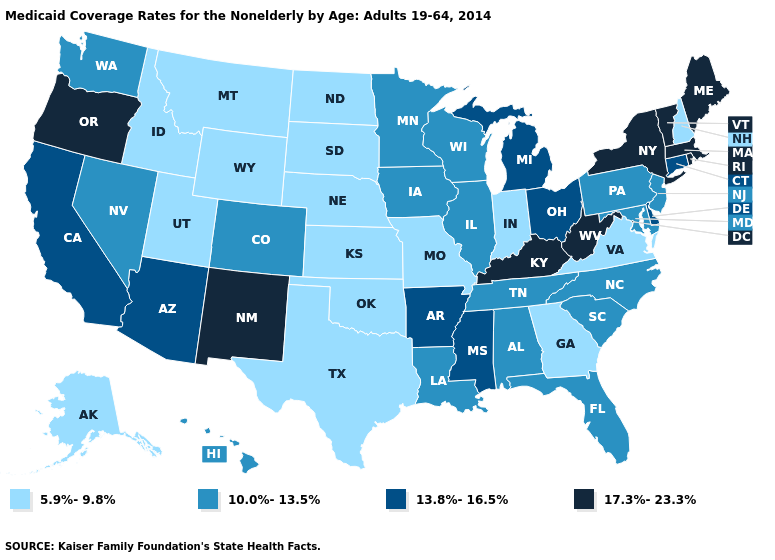What is the value of New Mexico?
Quick response, please. 17.3%-23.3%. Which states have the lowest value in the West?
Be succinct. Alaska, Idaho, Montana, Utah, Wyoming. Name the states that have a value in the range 10.0%-13.5%?
Be succinct. Alabama, Colorado, Florida, Hawaii, Illinois, Iowa, Louisiana, Maryland, Minnesota, Nevada, New Jersey, North Carolina, Pennsylvania, South Carolina, Tennessee, Washington, Wisconsin. Does Utah have the lowest value in the West?
Answer briefly. Yes. Is the legend a continuous bar?
Quick response, please. No. Among the states that border Texas , which have the highest value?
Quick response, please. New Mexico. Which states have the lowest value in the MidWest?
Keep it brief. Indiana, Kansas, Missouri, Nebraska, North Dakota, South Dakota. Name the states that have a value in the range 17.3%-23.3%?
Give a very brief answer. Kentucky, Maine, Massachusetts, New Mexico, New York, Oregon, Rhode Island, Vermont, West Virginia. What is the highest value in the USA?
Give a very brief answer. 17.3%-23.3%. How many symbols are there in the legend?
Give a very brief answer. 4. Does the map have missing data?
Short answer required. No. Name the states that have a value in the range 5.9%-9.8%?
Answer briefly. Alaska, Georgia, Idaho, Indiana, Kansas, Missouri, Montana, Nebraska, New Hampshire, North Dakota, Oklahoma, South Dakota, Texas, Utah, Virginia, Wyoming. What is the lowest value in the USA?
Quick response, please. 5.9%-9.8%. Name the states that have a value in the range 5.9%-9.8%?
Concise answer only. Alaska, Georgia, Idaho, Indiana, Kansas, Missouri, Montana, Nebraska, New Hampshire, North Dakota, Oklahoma, South Dakota, Texas, Utah, Virginia, Wyoming. What is the value of Washington?
Keep it brief. 10.0%-13.5%. 